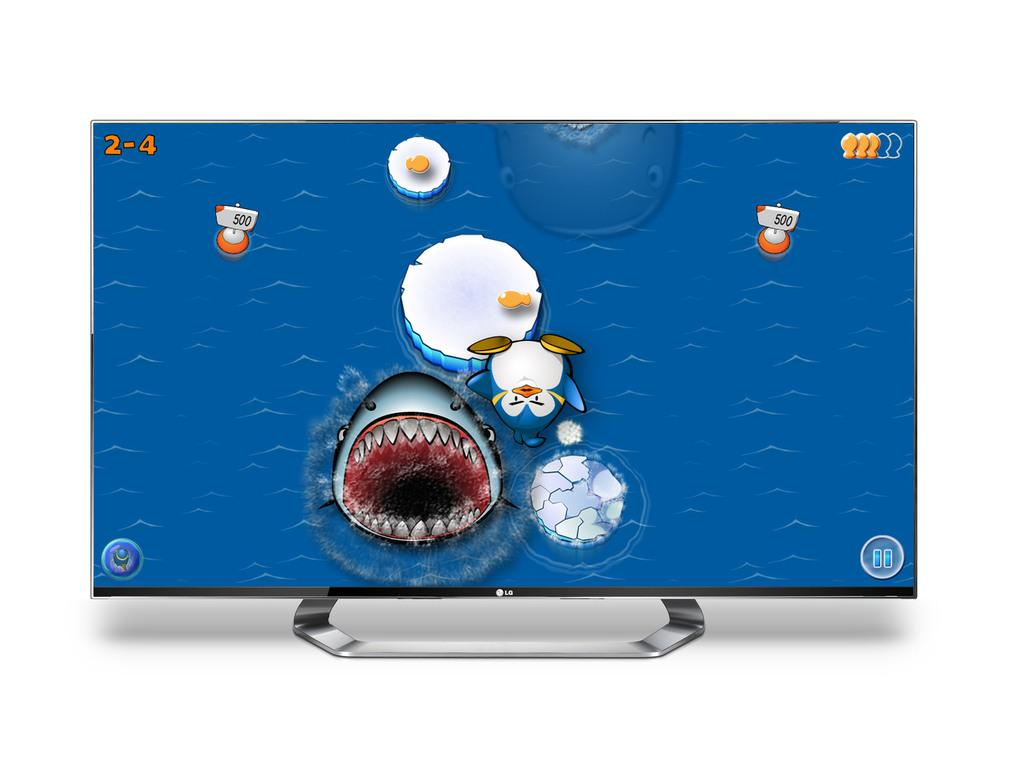<image>
Summarize the visual content of the image. An LG monitor showing some sort of game in progress. 